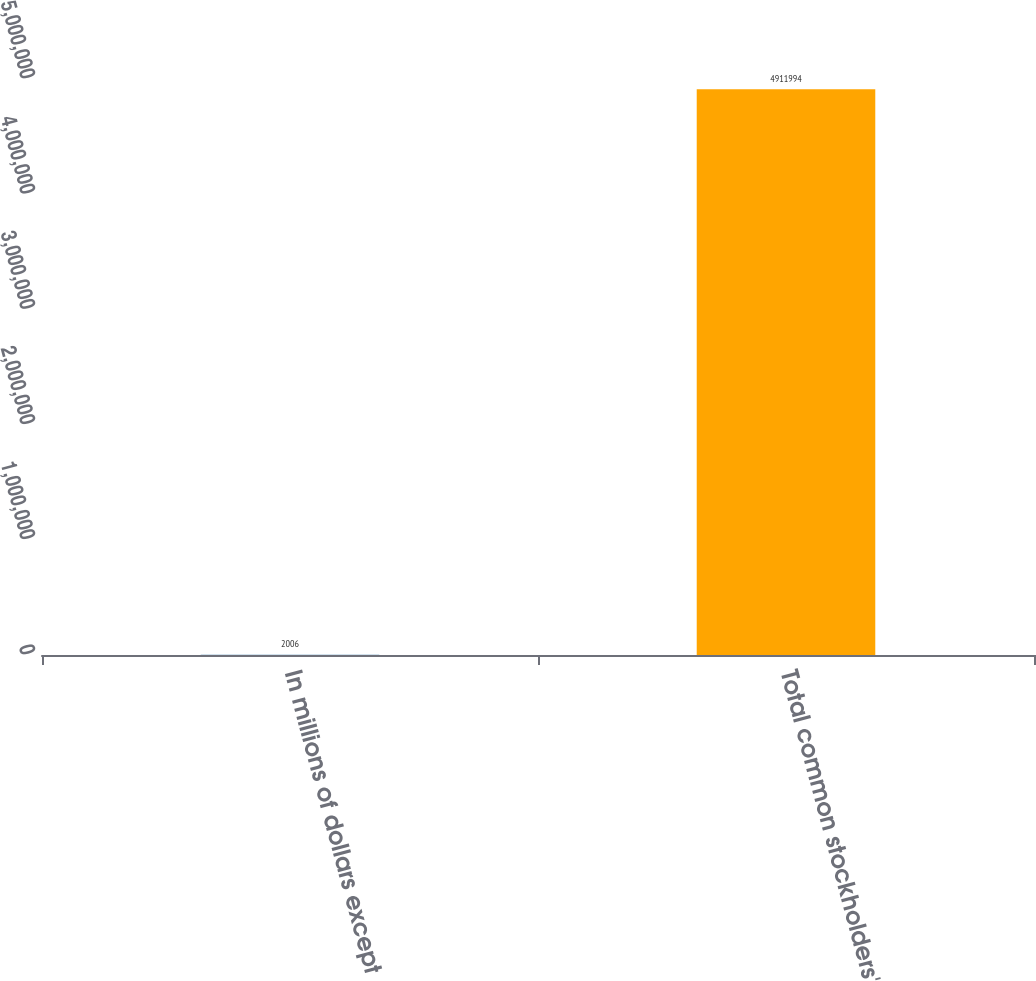Convert chart. <chart><loc_0><loc_0><loc_500><loc_500><bar_chart><fcel>In millions of dollars except<fcel>Total common stockholders'<nl><fcel>2006<fcel>4.91199e+06<nl></chart> 